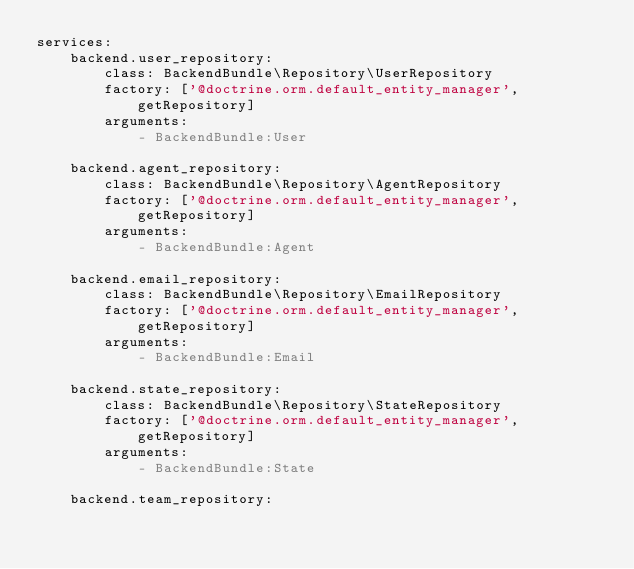<code> <loc_0><loc_0><loc_500><loc_500><_YAML_>services:
    backend.user_repository:
        class: BackendBundle\Repository\UserRepository
        factory: ['@doctrine.orm.default_entity_manager', getRepository]
        arguments:
            - BackendBundle:User

    backend.agent_repository:
        class: BackendBundle\Repository\AgentRepository
        factory: ['@doctrine.orm.default_entity_manager', getRepository]
        arguments:
            - BackendBundle:Agent

    backend.email_repository:
        class: BackendBundle\Repository\EmailRepository
        factory: ['@doctrine.orm.default_entity_manager', getRepository]
        arguments:
            - BackendBundle:Email

    backend.state_repository:
        class: BackendBundle\Repository\StateRepository
        factory: ['@doctrine.orm.default_entity_manager', getRepository]
        arguments:
            - BackendBundle:State

    backend.team_repository:</code> 